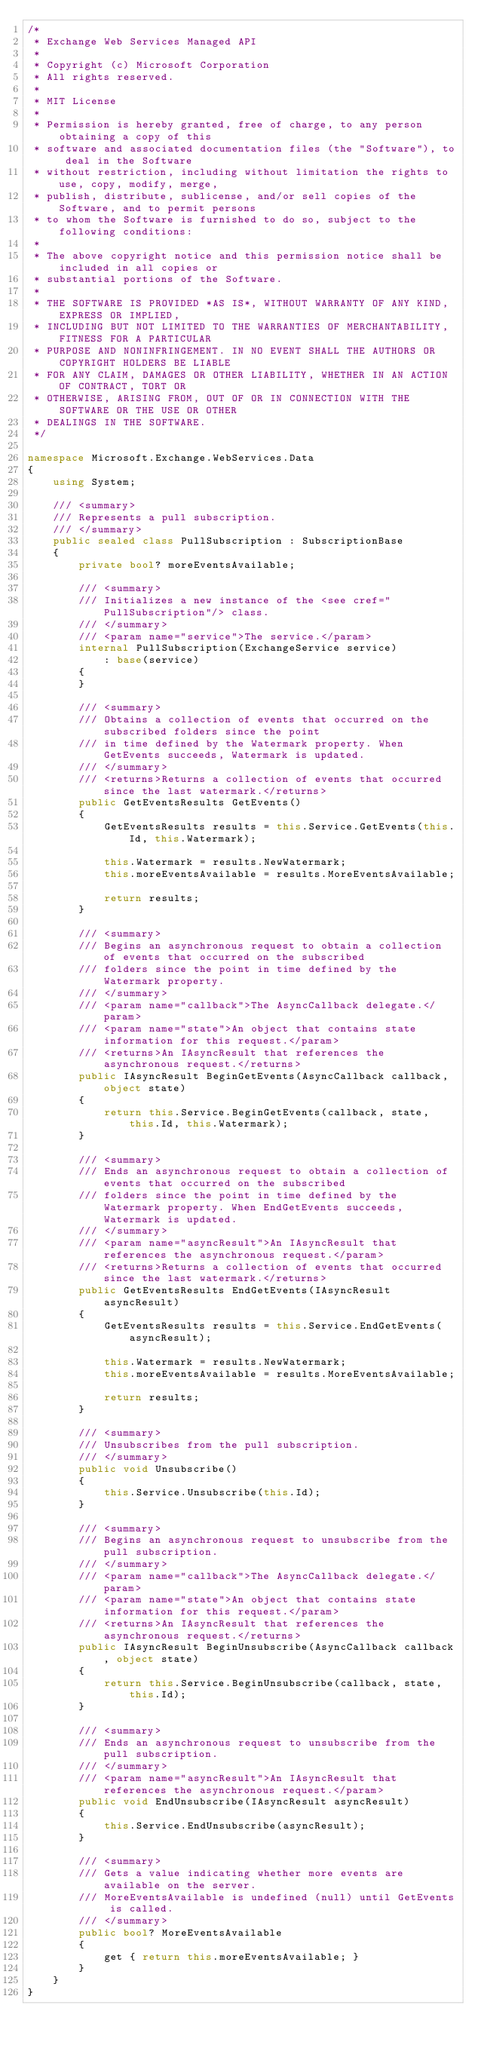Convert code to text. <code><loc_0><loc_0><loc_500><loc_500><_C#_>/*
 * Exchange Web Services Managed API
 *
 * Copyright (c) Microsoft Corporation
 * All rights reserved.
 *
 * MIT License
 *
 * Permission is hereby granted, free of charge, to any person obtaining a copy of this
 * software and associated documentation files (the "Software"), to deal in the Software
 * without restriction, including without limitation the rights to use, copy, modify, merge,
 * publish, distribute, sublicense, and/or sell copies of the Software, and to permit persons
 * to whom the Software is furnished to do so, subject to the following conditions:
 *
 * The above copyright notice and this permission notice shall be included in all copies or
 * substantial portions of the Software.
 *
 * THE SOFTWARE IS PROVIDED *AS IS*, WITHOUT WARRANTY OF ANY KIND, EXPRESS OR IMPLIED,
 * INCLUDING BUT NOT LIMITED TO THE WARRANTIES OF MERCHANTABILITY, FITNESS FOR A PARTICULAR
 * PURPOSE AND NONINFRINGEMENT. IN NO EVENT SHALL THE AUTHORS OR COPYRIGHT HOLDERS BE LIABLE
 * FOR ANY CLAIM, DAMAGES OR OTHER LIABILITY, WHETHER IN AN ACTION OF CONTRACT, TORT OR
 * OTHERWISE, ARISING FROM, OUT OF OR IN CONNECTION WITH THE SOFTWARE OR THE USE OR OTHER
 * DEALINGS IN THE SOFTWARE.
 */

namespace Microsoft.Exchange.WebServices.Data
{
    using System;

    /// <summary>
    /// Represents a pull subscription.
    /// </summary>
    public sealed class PullSubscription : SubscriptionBase
    {
        private bool? moreEventsAvailable;

        /// <summary>
        /// Initializes a new instance of the <see cref="PullSubscription"/> class.
        /// </summary>
        /// <param name="service">The service.</param>
        internal PullSubscription(ExchangeService service)
            : base(service)
        {
        }

        /// <summary>
        /// Obtains a collection of events that occurred on the subscribed folders since the point
        /// in time defined by the Watermark property. When GetEvents succeeds, Watermark is updated.
        /// </summary>
        /// <returns>Returns a collection of events that occurred since the last watermark.</returns>
        public GetEventsResults GetEvents()
        {
            GetEventsResults results = this.Service.GetEvents(this.Id, this.Watermark);

            this.Watermark = results.NewWatermark;
            this.moreEventsAvailable = results.MoreEventsAvailable;

            return results;
        }

        /// <summary>
        /// Begins an asynchronous request to obtain a collection of events that occurred on the subscribed 
        /// folders since the point in time defined by the Watermark property.
        /// </summary>
        /// <param name="callback">The AsyncCallback delegate.</param>
        /// <param name="state">An object that contains state information for this request.</param>
        /// <returns>An IAsyncResult that references the asynchronous request.</returns>
        public IAsyncResult BeginGetEvents(AsyncCallback callback, object state)
        {
            return this.Service.BeginGetEvents(callback, state, this.Id, this.Watermark);
        }

        /// <summary>
        /// Ends an asynchronous request to obtain a collection of events that occurred on the subscribed 
        /// folders since the point in time defined by the Watermark property. When EndGetEvents succeeds, Watermark is updated.
        /// </summary>
        /// <param name="asyncResult">An IAsyncResult that references the asynchronous request.</param>
        /// <returns>Returns a collection of events that occurred since the last watermark.</returns>
        public GetEventsResults EndGetEvents(IAsyncResult asyncResult)
        {
            GetEventsResults results = this.Service.EndGetEvents(asyncResult);

            this.Watermark = results.NewWatermark;
            this.moreEventsAvailable = results.MoreEventsAvailable;

            return results;
        }

        /// <summary>
        /// Unsubscribes from the pull subscription.
        /// </summary>
        public void Unsubscribe()
        {
            this.Service.Unsubscribe(this.Id);
        }

        /// <summary>
        /// Begins an asynchronous request to unsubscribe from the pull subscription. 
        /// </summary>
        /// <param name="callback">The AsyncCallback delegate.</param>
        /// <param name="state">An object that contains state information for this request.</param>
        /// <returns>An IAsyncResult that references the asynchronous request.</returns>
        public IAsyncResult BeginUnsubscribe(AsyncCallback callback, object state)
        {
            return this.Service.BeginUnsubscribe(callback, state, this.Id);
        }

        /// <summary>
        /// Ends an asynchronous request to unsubscribe from the pull subscription. 
        /// </summary>
        /// <param name="asyncResult">An IAsyncResult that references the asynchronous request.</param>
        public void EndUnsubscribe(IAsyncResult asyncResult)
        {
            this.Service.EndUnsubscribe(asyncResult);
        }

        /// <summary>
        /// Gets a value indicating whether more events are available on the server.
        /// MoreEventsAvailable is undefined (null) until GetEvents is called.
        /// </summary>
        public bool? MoreEventsAvailable
        {
            get { return this.moreEventsAvailable; }
        }
    }
}</code> 